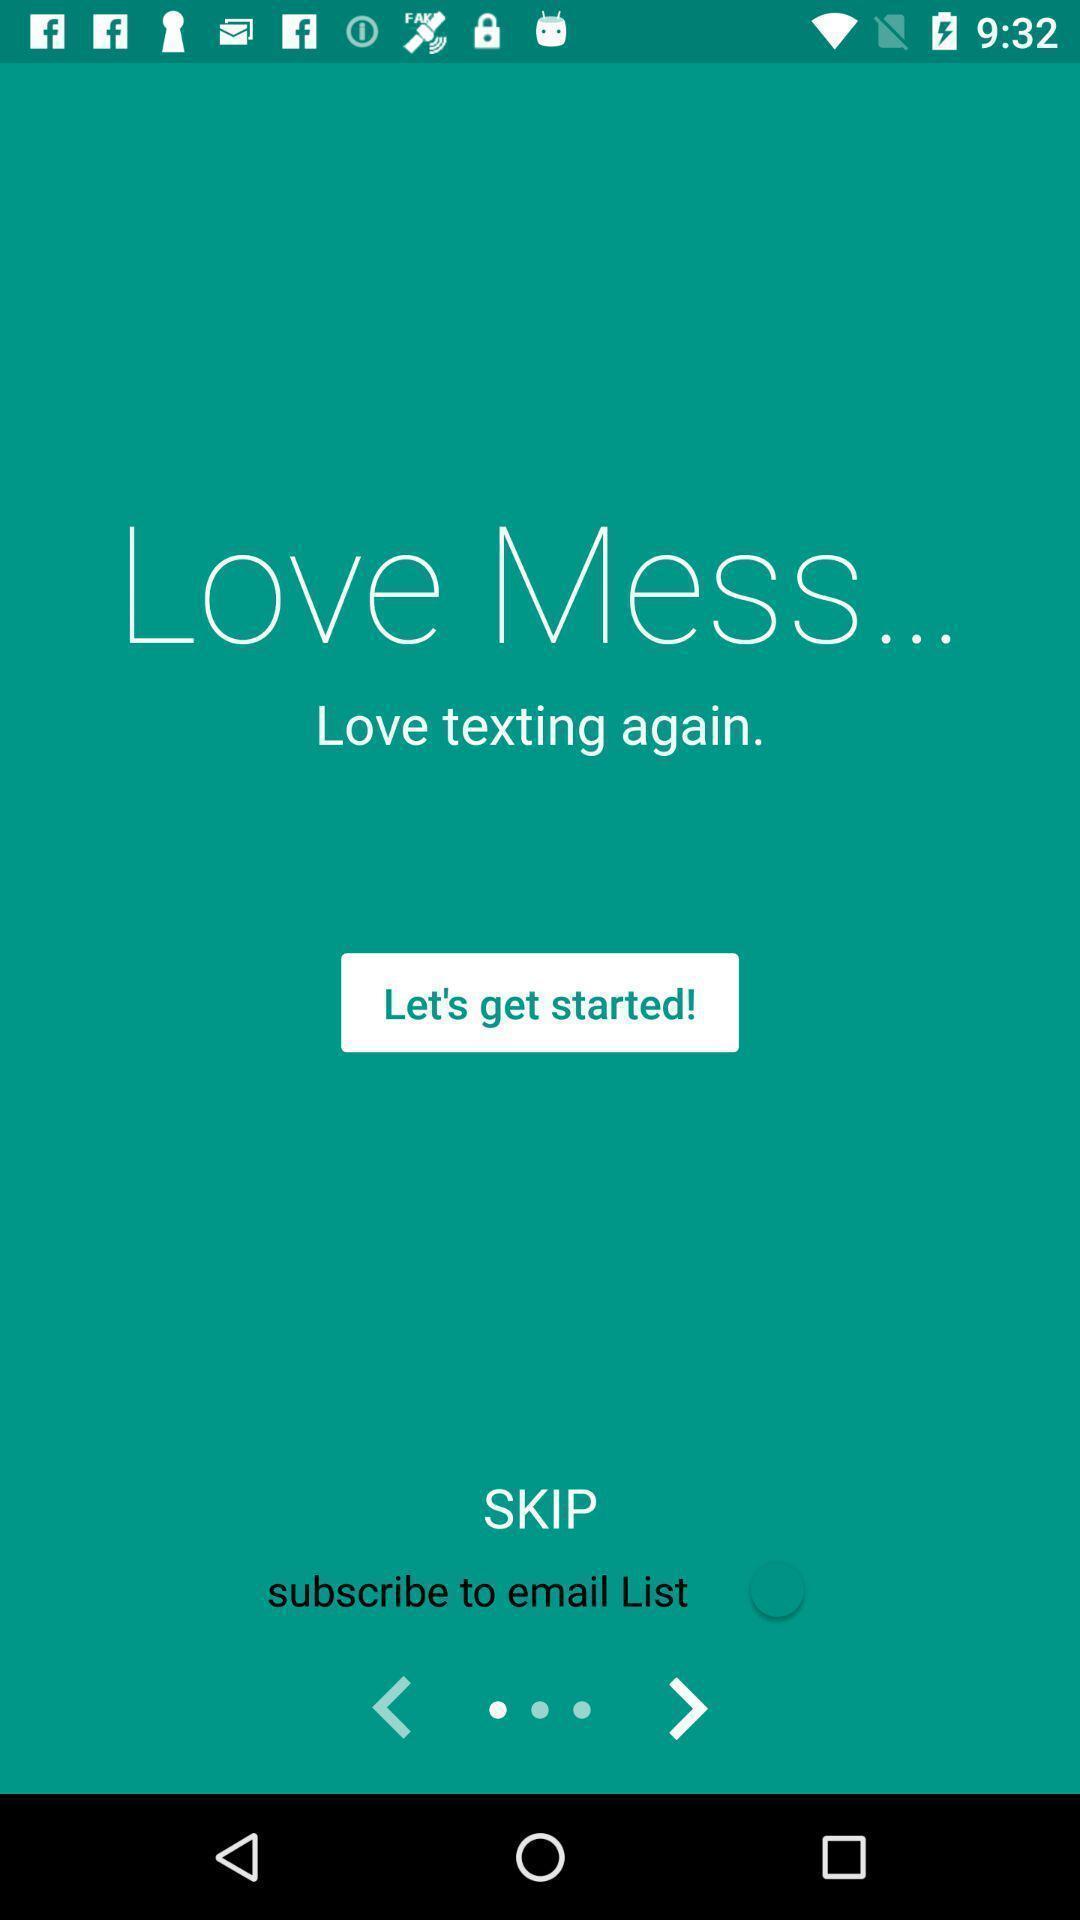Describe the visual elements of this screenshot. Welcome page. 